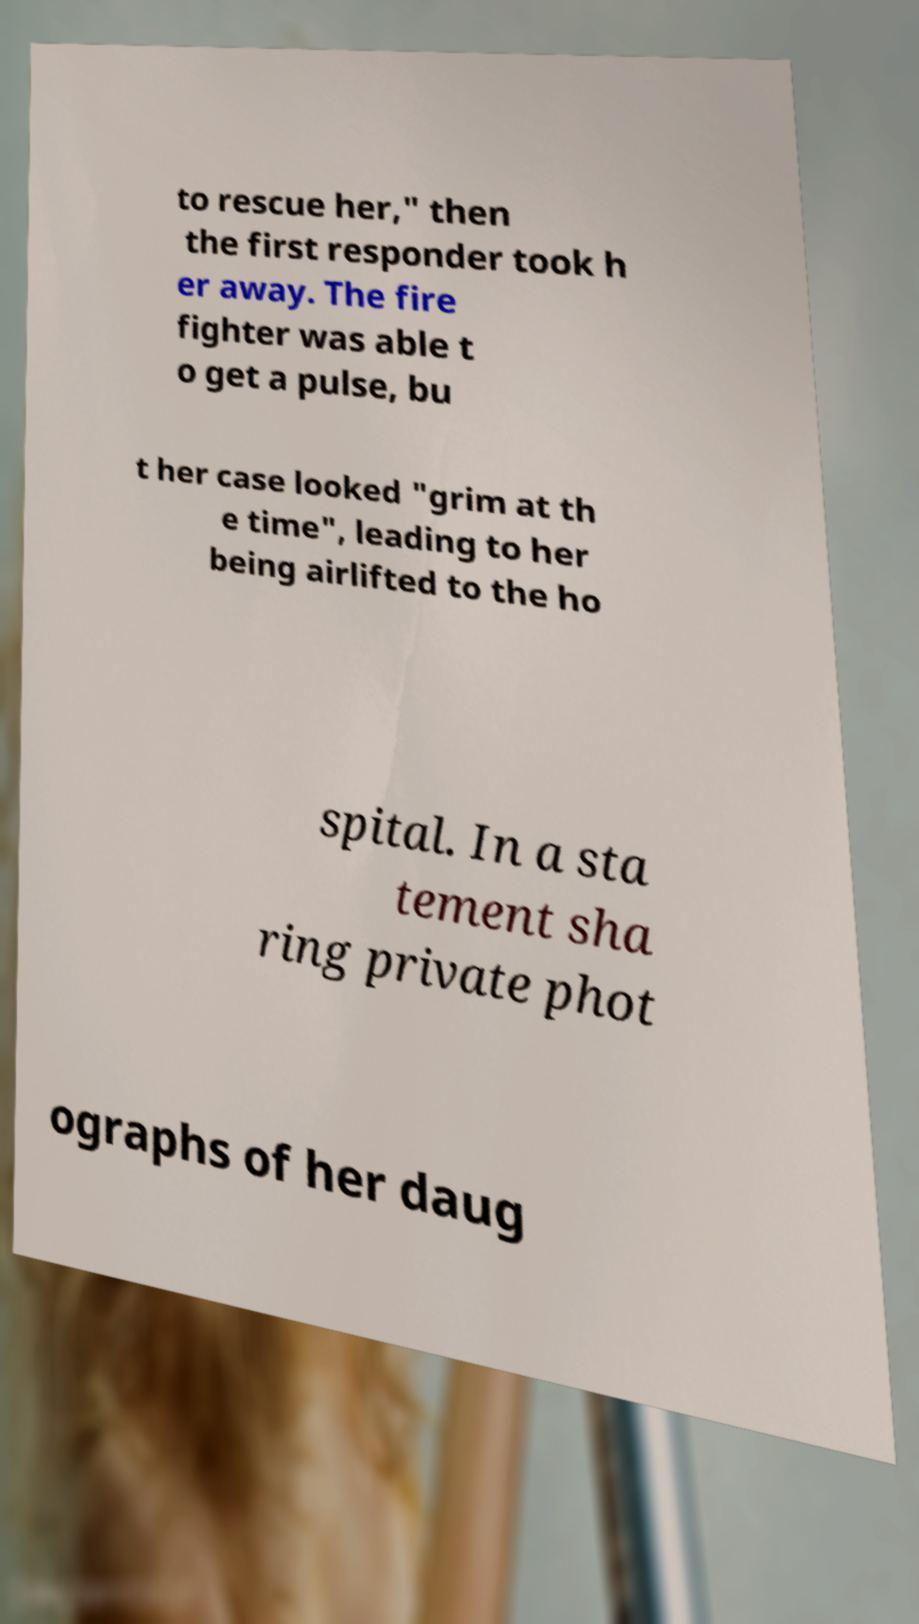For documentation purposes, I need the text within this image transcribed. Could you provide that? to rescue her," then the first responder took h er away. The fire fighter was able t o get a pulse, bu t her case looked "grim at th e time", leading to her being airlifted to the ho spital. In a sta tement sha ring private phot ographs of her daug 